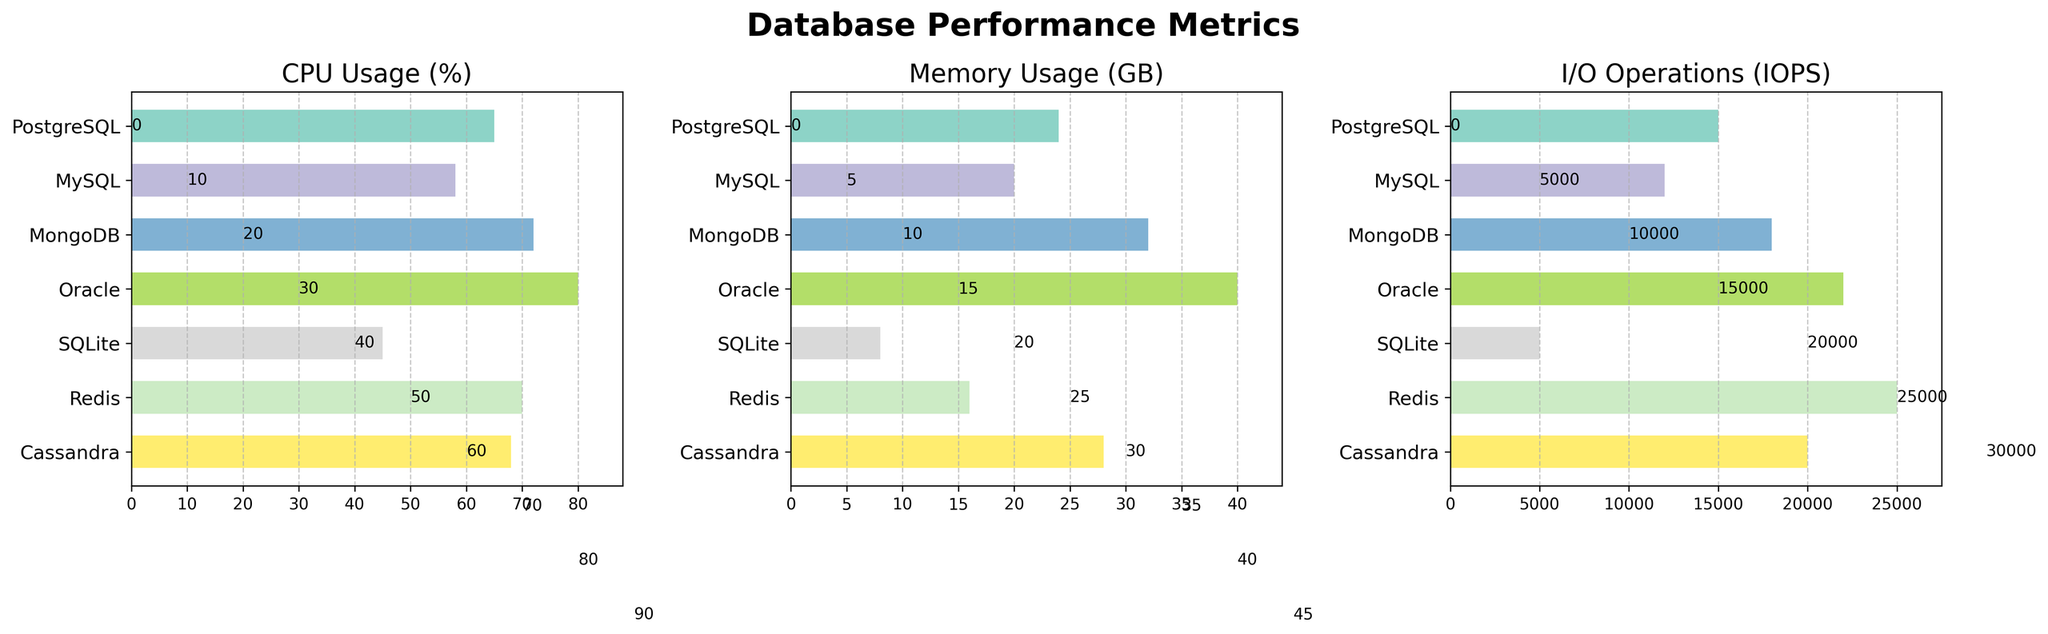Which database has the highest CPU usage? The plot of CPU Usage (%) shows the bars for each database. The database with the longest bar (80%) is Oracle.
Answer: Oracle Which database utilizes the least memory? The bar for Memory Usage (GB) indicates the memory usage for each database. The shortest bar (8 GB) represents SQLite.
Answer: SQLite What is the difference in I/O operations between MongoDB and Cassandra? According to the I/O Operations (IOPS) subplot, MongoDB has 18000 IOPS, and Cassandra has 20000 IOPS. The difference is 20000 - 18000 = 2000 IOPS.
Answer: 2000 How many databases have a CPU usage higher than 65%? By examining the CPU Usage (%) subplot, we see the bars for MongoDB (72%), Oracle (80%), Redis (70%), and Cassandra (68%) are greater than 65%. Thus, there are 4 such databases.
Answer: 4 Which database has the second highest memory usage? In the Memory Usage (GB) subplot, Oracle has the highest memory usage (40 GB), and MongoDB has the second highest (32 GB).
Answer: MongoDB What is the average I/O operations per second (IOPS) across all databases? Summing up the I/O Operations (15000 + 12000 + 18000 + 22000 + 5000 + 25000 + 20000) gives 117000. Dividing this by the number of databases (7) results in 117000 / 7 ≈ 16714 IOPS.
Answer: ≈16714 Which database has a lower CPU usage but higher I/O operations than MySQL? Comparing the CPU and I/O plots: MySQL has 58% CPU usage and 12000 IOPS. SQLite has a lower CPU usage (45%) but also lower I/O operations (5000). Redis has both higher CPU usage (70%) and higher I/O operations (25000). Thus, there isn't a database that meets both conditions.
Answer: None What is the total memory usage of PostgreSQL and Redis combined? From the Memory Usage (GB) subplot, PostgreSQL uses 24 GB and Redis uses 16 GB. Their combined memory usage is 24 + 16 = 40 GB.
Answer: 40 Is there any database that has the highest value in more than one performance metric? Oracle has the highest bars in both CPU Usage (80%) and Memory Usage (40 GB) subplots.
Answer: Yes, Oracle Which databases have lower I/O operations than the average I/O operations? Previously calculated, the average IOPS is ≈16714. Databases with IOPS less than this average are PostgreSQL (15000), MySQL (12000), SQLite (5000), and MongoDB (18000), which is slightly above the average. Thus, PostgreSQL, MySQL, and SQLite have lower I/O operations.
Answer: PostgreSQL, MySQL, SQLite 